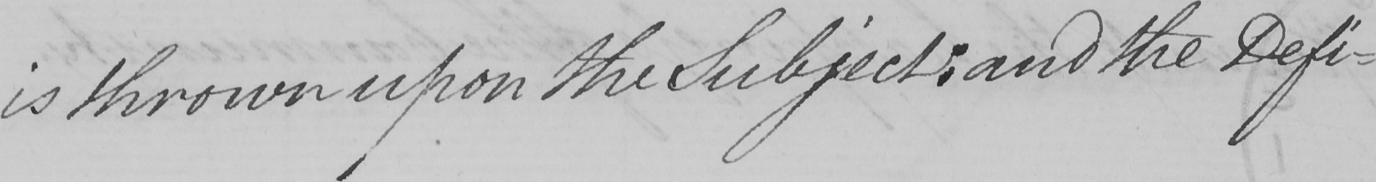Please transcribe the handwritten text in this image. is thrown upon the Subject :  and the Defi- 